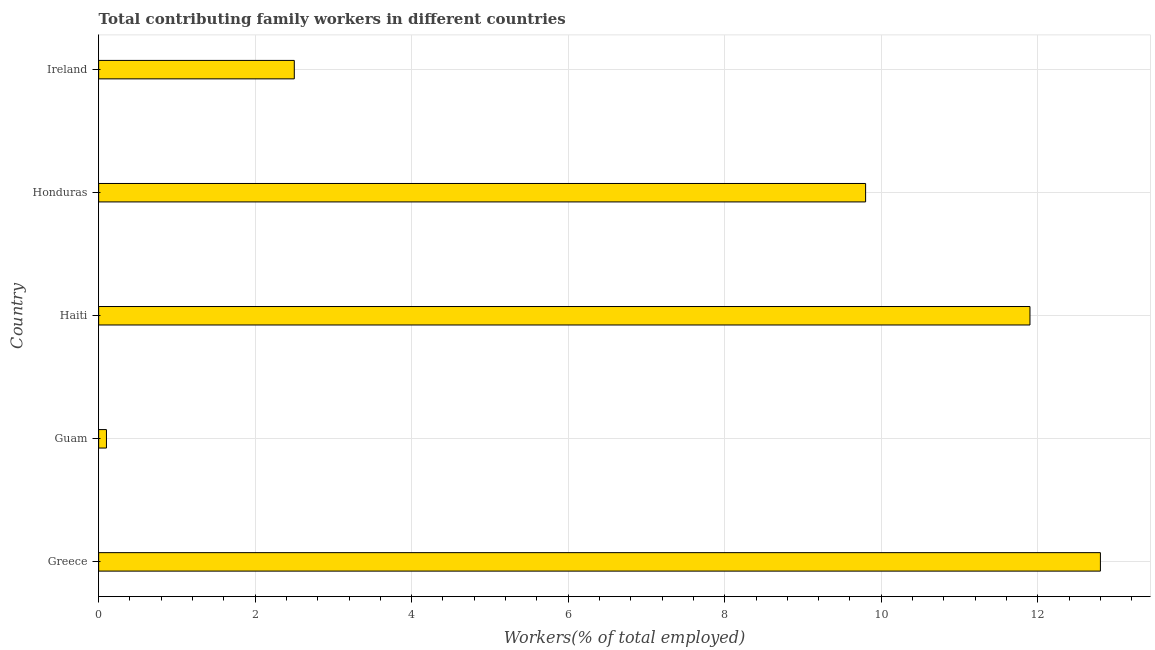Does the graph contain grids?
Offer a terse response. Yes. What is the title of the graph?
Keep it short and to the point. Total contributing family workers in different countries. What is the label or title of the X-axis?
Give a very brief answer. Workers(% of total employed). What is the contributing family workers in Haiti?
Offer a terse response. 11.9. Across all countries, what is the maximum contributing family workers?
Offer a very short reply. 12.8. Across all countries, what is the minimum contributing family workers?
Your answer should be very brief. 0.1. In which country was the contributing family workers minimum?
Make the answer very short. Guam. What is the sum of the contributing family workers?
Provide a short and direct response. 37.1. What is the difference between the contributing family workers in Guam and Honduras?
Ensure brevity in your answer.  -9.7. What is the average contributing family workers per country?
Keep it short and to the point. 7.42. What is the median contributing family workers?
Offer a terse response. 9.8. In how many countries, is the contributing family workers greater than 3.6 %?
Your answer should be compact. 3. What is the ratio of the contributing family workers in Greece to that in Ireland?
Offer a very short reply. 5.12. What is the difference between the highest and the second highest contributing family workers?
Provide a short and direct response. 0.9. Is the sum of the contributing family workers in Guam and Haiti greater than the maximum contributing family workers across all countries?
Provide a succinct answer. No. What is the difference between the highest and the lowest contributing family workers?
Your response must be concise. 12.7. In how many countries, is the contributing family workers greater than the average contributing family workers taken over all countries?
Give a very brief answer. 3. What is the Workers(% of total employed) of Greece?
Offer a terse response. 12.8. What is the Workers(% of total employed) of Guam?
Your answer should be very brief. 0.1. What is the Workers(% of total employed) in Haiti?
Ensure brevity in your answer.  11.9. What is the Workers(% of total employed) in Honduras?
Provide a short and direct response. 9.8. What is the Workers(% of total employed) in Ireland?
Make the answer very short. 2.5. What is the difference between the Workers(% of total employed) in Greece and Honduras?
Keep it short and to the point. 3. What is the difference between the Workers(% of total employed) in Guam and Honduras?
Keep it short and to the point. -9.7. What is the difference between the Workers(% of total employed) in Haiti and Honduras?
Provide a short and direct response. 2.1. What is the ratio of the Workers(% of total employed) in Greece to that in Guam?
Give a very brief answer. 128. What is the ratio of the Workers(% of total employed) in Greece to that in Haiti?
Offer a terse response. 1.08. What is the ratio of the Workers(% of total employed) in Greece to that in Honduras?
Your answer should be very brief. 1.31. What is the ratio of the Workers(% of total employed) in Greece to that in Ireland?
Provide a succinct answer. 5.12. What is the ratio of the Workers(% of total employed) in Guam to that in Haiti?
Offer a very short reply. 0.01. What is the ratio of the Workers(% of total employed) in Guam to that in Honduras?
Offer a terse response. 0.01. What is the ratio of the Workers(% of total employed) in Guam to that in Ireland?
Ensure brevity in your answer.  0.04. What is the ratio of the Workers(% of total employed) in Haiti to that in Honduras?
Offer a terse response. 1.21. What is the ratio of the Workers(% of total employed) in Haiti to that in Ireland?
Your answer should be very brief. 4.76. What is the ratio of the Workers(% of total employed) in Honduras to that in Ireland?
Offer a very short reply. 3.92. 